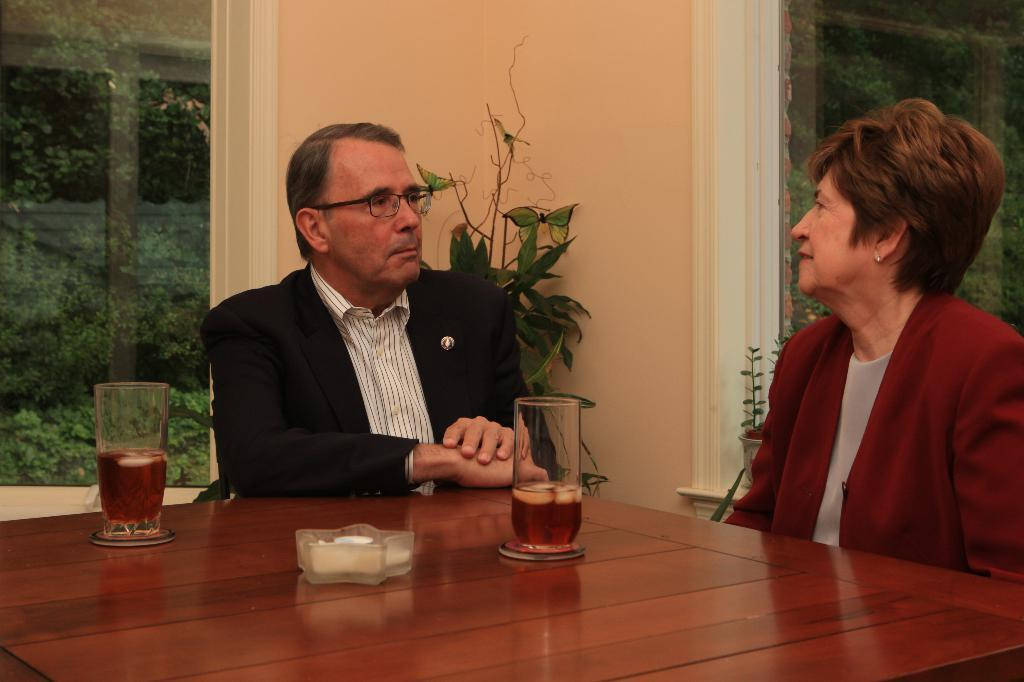How many people are in the image? There are two persons in the image. Can you describe the gender of each person? One person is a man, and the other person is a woman. What are the positions of the persons in the image? Both persons are sitting on chairs. What is located in front of the persons? There is a table in front of them. What objects can be seen on the table? There are two wine glasses on the table. What type of lizards can be seen crawling on the table in the image? There are no lizards present in the image; the table only has two wine glasses on it. 